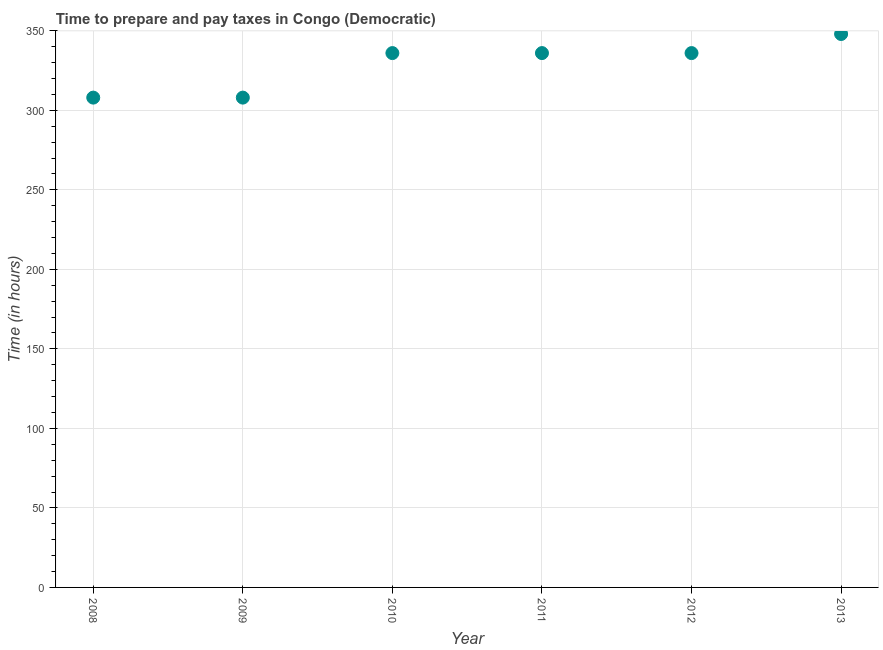What is the time to prepare and pay taxes in 2011?
Keep it short and to the point. 336. Across all years, what is the maximum time to prepare and pay taxes?
Your answer should be compact. 348. Across all years, what is the minimum time to prepare and pay taxes?
Make the answer very short. 308. In which year was the time to prepare and pay taxes maximum?
Offer a terse response. 2013. What is the sum of the time to prepare and pay taxes?
Your answer should be compact. 1972. What is the average time to prepare and pay taxes per year?
Give a very brief answer. 328.67. What is the median time to prepare and pay taxes?
Keep it short and to the point. 336. What is the ratio of the time to prepare and pay taxes in 2009 to that in 2011?
Provide a short and direct response. 0.92. Is the time to prepare and pay taxes in 2008 less than that in 2011?
Offer a very short reply. Yes. Is the difference between the time to prepare and pay taxes in 2009 and 2012 greater than the difference between any two years?
Your answer should be compact. No. What is the difference between the highest and the lowest time to prepare and pay taxes?
Offer a terse response. 40. In how many years, is the time to prepare and pay taxes greater than the average time to prepare and pay taxes taken over all years?
Your answer should be compact. 4. How many dotlines are there?
Ensure brevity in your answer.  1. How many years are there in the graph?
Offer a very short reply. 6. What is the difference between two consecutive major ticks on the Y-axis?
Your answer should be compact. 50. Does the graph contain grids?
Keep it short and to the point. Yes. What is the title of the graph?
Provide a succinct answer. Time to prepare and pay taxes in Congo (Democratic). What is the label or title of the Y-axis?
Your answer should be very brief. Time (in hours). What is the Time (in hours) in 2008?
Your response must be concise. 308. What is the Time (in hours) in 2009?
Provide a succinct answer. 308. What is the Time (in hours) in 2010?
Make the answer very short. 336. What is the Time (in hours) in 2011?
Keep it short and to the point. 336. What is the Time (in hours) in 2012?
Offer a very short reply. 336. What is the Time (in hours) in 2013?
Your answer should be compact. 348. What is the difference between the Time (in hours) in 2008 and 2009?
Ensure brevity in your answer.  0. What is the difference between the Time (in hours) in 2008 and 2011?
Provide a short and direct response. -28. What is the difference between the Time (in hours) in 2008 and 2012?
Your response must be concise. -28. What is the difference between the Time (in hours) in 2009 and 2012?
Your response must be concise. -28. What is the difference between the Time (in hours) in 2011 and 2012?
Your response must be concise. 0. What is the ratio of the Time (in hours) in 2008 to that in 2009?
Your answer should be compact. 1. What is the ratio of the Time (in hours) in 2008 to that in 2010?
Your response must be concise. 0.92. What is the ratio of the Time (in hours) in 2008 to that in 2011?
Your answer should be compact. 0.92. What is the ratio of the Time (in hours) in 2008 to that in 2012?
Ensure brevity in your answer.  0.92. What is the ratio of the Time (in hours) in 2008 to that in 2013?
Make the answer very short. 0.89. What is the ratio of the Time (in hours) in 2009 to that in 2010?
Offer a terse response. 0.92. What is the ratio of the Time (in hours) in 2009 to that in 2011?
Offer a terse response. 0.92. What is the ratio of the Time (in hours) in 2009 to that in 2012?
Keep it short and to the point. 0.92. What is the ratio of the Time (in hours) in 2009 to that in 2013?
Your response must be concise. 0.89. What is the ratio of the Time (in hours) in 2010 to that in 2011?
Provide a succinct answer. 1. What is the ratio of the Time (in hours) in 2011 to that in 2013?
Your answer should be very brief. 0.97. 